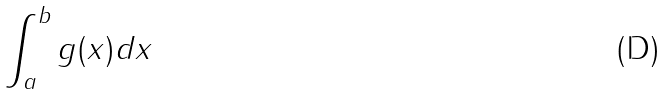Convert formula to latex. <formula><loc_0><loc_0><loc_500><loc_500>\int _ { a } ^ { b } g ( x ) d x</formula> 